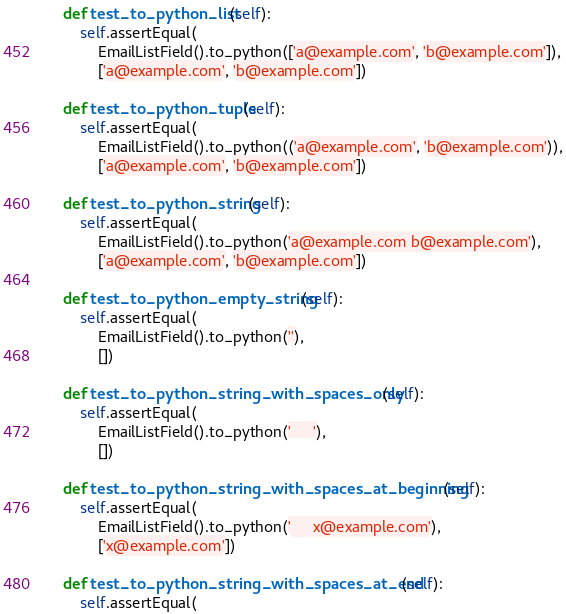<code> <loc_0><loc_0><loc_500><loc_500><_Python_>    def test_to_python_list(self):
        self.assertEqual(
            EmailListField().to_python(['a@example.com', 'b@example.com']),
            ['a@example.com', 'b@example.com'])

    def test_to_python_tuple(self):
        self.assertEqual(
            EmailListField().to_python(('a@example.com', 'b@example.com')),
            ['a@example.com', 'b@example.com'])

    def test_to_python_string(self):
        self.assertEqual(
            EmailListField().to_python('a@example.com b@example.com'),
            ['a@example.com', 'b@example.com'])

    def test_to_python_empty_string(self):
        self.assertEqual(
            EmailListField().to_python(''),
            [])

    def test_to_python_string_with_spaces_only(self):
        self.assertEqual(
            EmailListField().to_python('     '),
            [])

    def test_to_python_string_with_spaces_at_beginning(self):
        self.assertEqual(
            EmailListField().to_python('     x@example.com'),
            ['x@example.com'])

    def test_to_python_string_with_spaces_at_end(self):
        self.assertEqual(</code> 